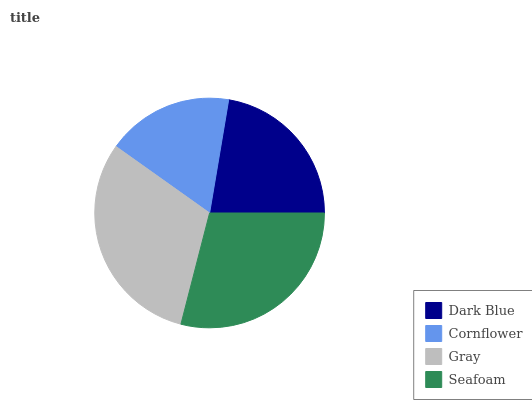Is Cornflower the minimum?
Answer yes or no. Yes. Is Gray the maximum?
Answer yes or no. Yes. Is Gray the minimum?
Answer yes or no. No. Is Cornflower the maximum?
Answer yes or no. No. Is Gray greater than Cornflower?
Answer yes or no. Yes. Is Cornflower less than Gray?
Answer yes or no. Yes. Is Cornflower greater than Gray?
Answer yes or no. No. Is Gray less than Cornflower?
Answer yes or no. No. Is Seafoam the high median?
Answer yes or no. Yes. Is Dark Blue the low median?
Answer yes or no. Yes. Is Cornflower the high median?
Answer yes or no. No. Is Gray the low median?
Answer yes or no. No. 